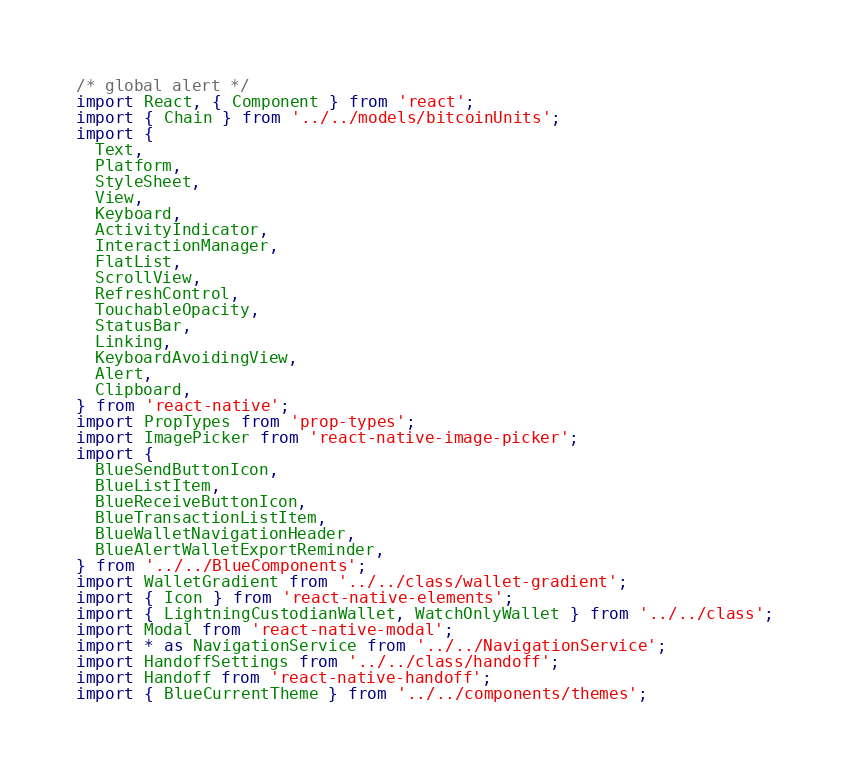Convert code to text. <code><loc_0><loc_0><loc_500><loc_500><_JavaScript_>/* global alert */
import React, { Component } from 'react';
import { Chain } from '../../models/bitcoinUnits';
import {
  Text,
  Platform,
  StyleSheet,
  View,
  Keyboard,
  ActivityIndicator,
  InteractionManager,
  FlatList,
  ScrollView,
  RefreshControl,
  TouchableOpacity,
  StatusBar,
  Linking,
  KeyboardAvoidingView,
  Alert,
  Clipboard,
} from 'react-native';
import PropTypes from 'prop-types';
import ImagePicker from 'react-native-image-picker';
import {
  BlueSendButtonIcon,
  BlueListItem,
  BlueReceiveButtonIcon,
  BlueTransactionListItem,
  BlueWalletNavigationHeader,
  BlueAlertWalletExportReminder,
} from '../../BlueComponents';
import WalletGradient from '../../class/wallet-gradient';
import { Icon } from 'react-native-elements';
import { LightningCustodianWallet, WatchOnlyWallet } from '../../class';
import Modal from 'react-native-modal';
import * as NavigationService from '../../NavigationService';
import HandoffSettings from '../../class/handoff';
import Handoff from 'react-native-handoff';
import { BlueCurrentTheme } from '../../components/themes';</code> 